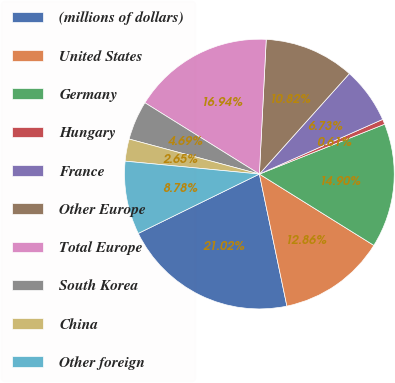Convert chart. <chart><loc_0><loc_0><loc_500><loc_500><pie_chart><fcel>(millions of dollars)<fcel>United States<fcel>Germany<fcel>Hungary<fcel>France<fcel>Other Europe<fcel>Total Europe<fcel>South Korea<fcel>China<fcel>Other foreign<nl><fcel>21.02%<fcel>12.86%<fcel>14.9%<fcel>0.61%<fcel>6.73%<fcel>10.82%<fcel>16.94%<fcel>4.69%<fcel>2.65%<fcel>8.78%<nl></chart> 